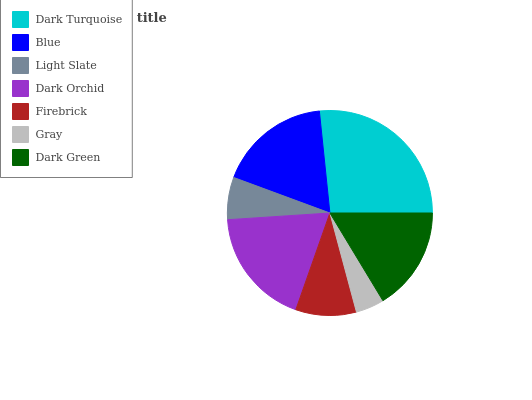Is Gray the minimum?
Answer yes or no. Yes. Is Dark Turquoise the maximum?
Answer yes or no. Yes. Is Blue the minimum?
Answer yes or no. No. Is Blue the maximum?
Answer yes or no. No. Is Dark Turquoise greater than Blue?
Answer yes or no. Yes. Is Blue less than Dark Turquoise?
Answer yes or no. Yes. Is Blue greater than Dark Turquoise?
Answer yes or no. No. Is Dark Turquoise less than Blue?
Answer yes or no. No. Is Dark Green the high median?
Answer yes or no. Yes. Is Dark Green the low median?
Answer yes or no. Yes. Is Firebrick the high median?
Answer yes or no. No. Is Firebrick the low median?
Answer yes or no. No. 